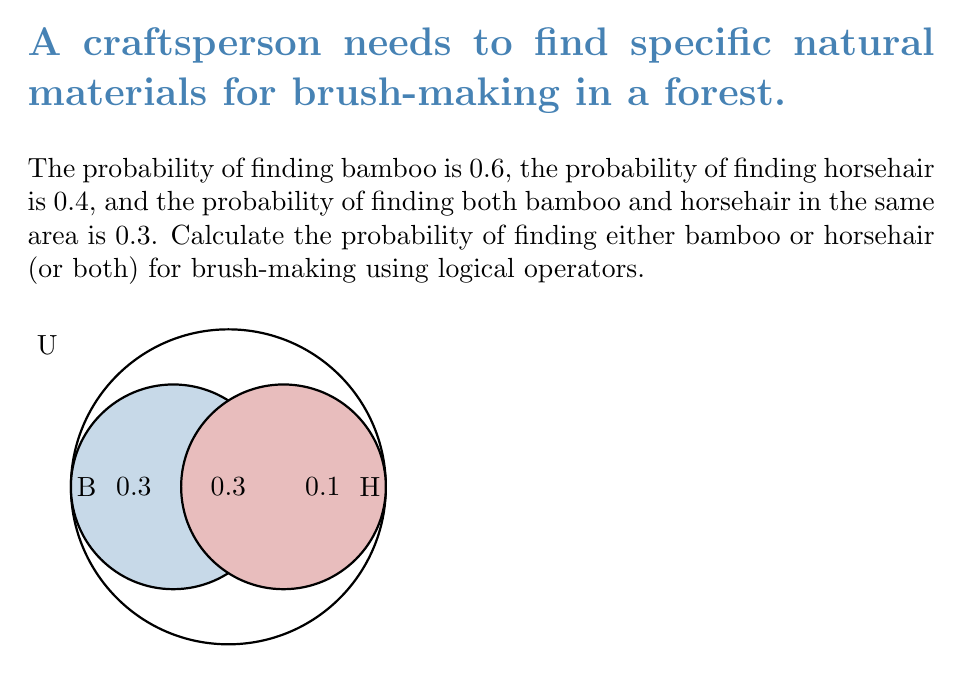Teach me how to tackle this problem. Let's approach this step-by-step using set theory and logical operators:

1) Let B be the event of finding bamboo and H be the event of finding horsehair.

2) We are given:
   $P(B) = 0.6$
   $P(H) = 0.4$
   $P(B \cap H) = 0.3$ (probability of both occurring)

3) We need to find $P(B \cup H)$, which is the probability of finding either bamboo or horsehair or both.

4) We can use the addition rule of probability:
   $P(B \cup H) = P(B) + P(H) - P(B \cap H)$

5) This is because if we simply add $P(B)$ and $P(H)$, we would be counting the intersection twice, so we need to subtract it once.

6) Substituting the values:
   $P(B \cup H) = 0.6 + 0.4 - 0.3$

7) Calculating:
   $P(B \cup H) = 1 - 0.3 = 0.7$

Therefore, the probability of finding either bamboo or horsehair (or both) is 0.7 or 70%.
Answer: $0.7$ 